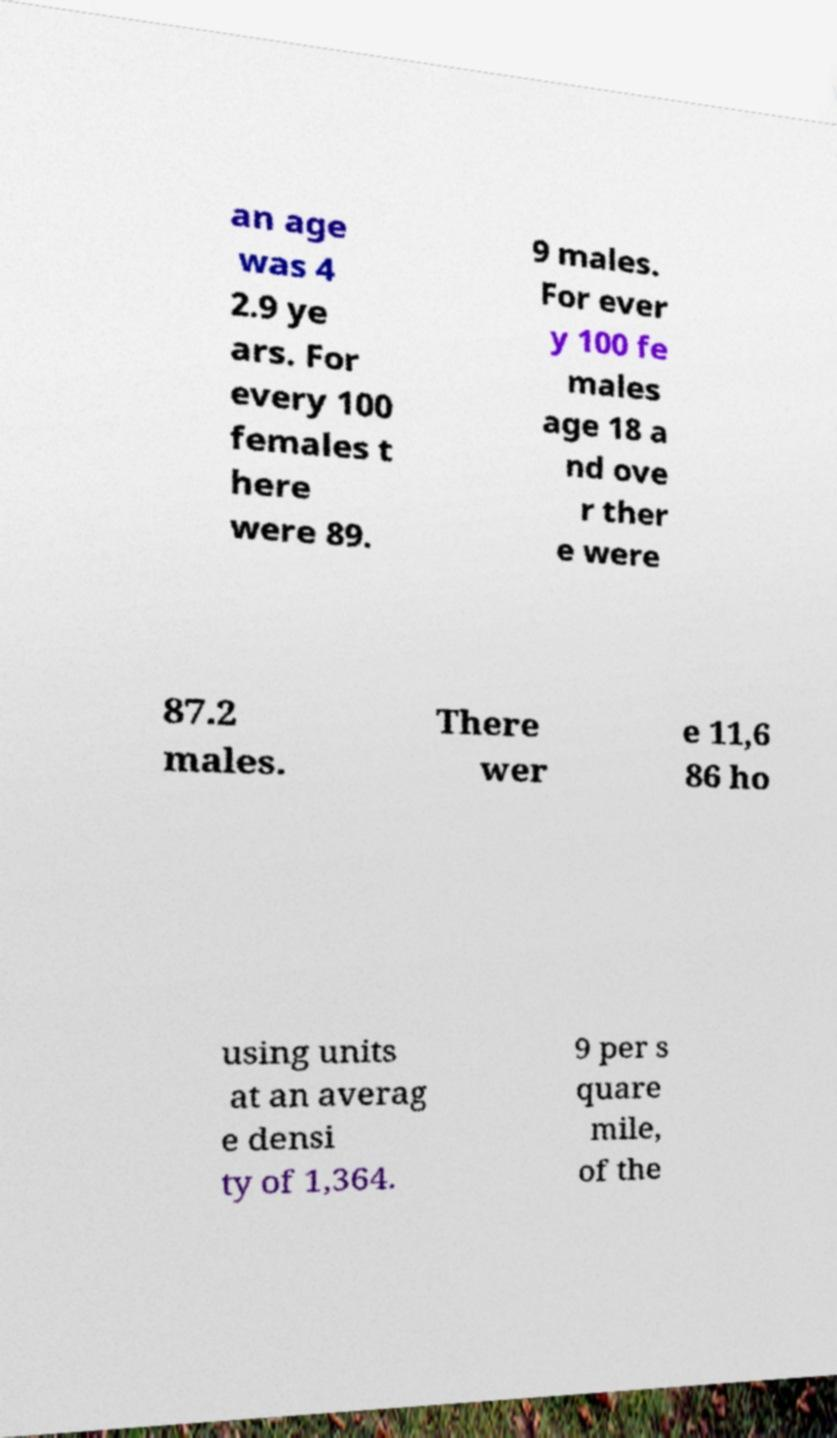Could you extract and type out the text from this image? an age was 4 2.9 ye ars. For every 100 females t here were 89. 9 males. For ever y 100 fe males age 18 a nd ove r ther e were 87.2 males. There wer e 11,6 86 ho using units at an averag e densi ty of 1,364. 9 per s quare mile, of the 